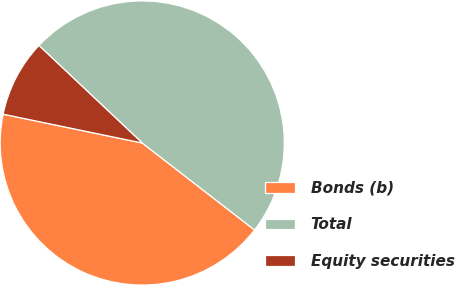Convert chart to OTSL. <chart><loc_0><loc_0><loc_500><loc_500><pie_chart><fcel>Bonds (b)<fcel>Total<fcel>Equity securities<nl><fcel>42.77%<fcel>48.45%<fcel>8.79%<nl></chart> 